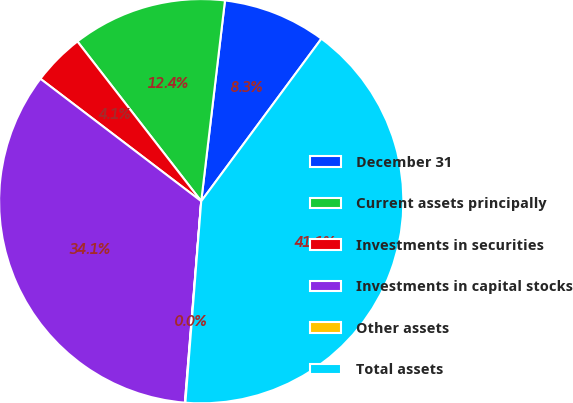<chart> <loc_0><loc_0><loc_500><loc_500><pie_chart><fcel>December 31<fcel>Current assets principally<fcel>Investments in securities<fcel>Investments in capital stocks<fcel>Other assets<fcel>Total assets<nl><fcel>8.26%<fcel>12.37%<fcel>4.15%<fcel>34.07%<fcel>0.04%<fcel>41.12%<nl></chart> 